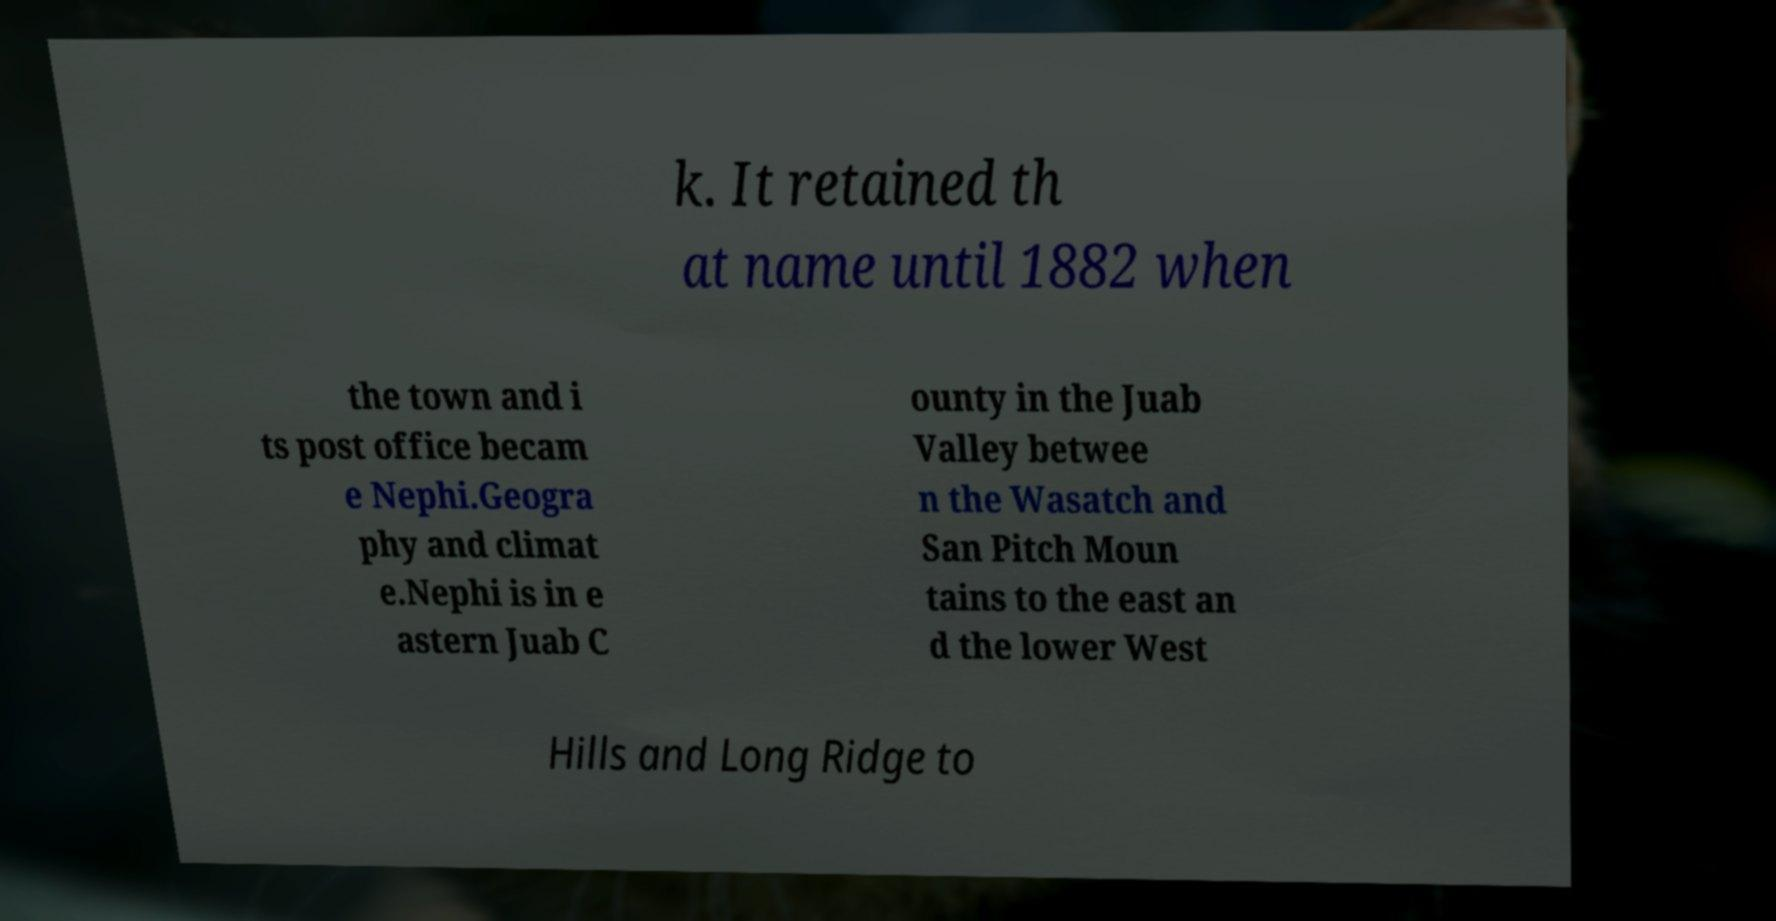I need the written content from this picture converted into text. Can you do that? k. It retained th at name until 1882 when the town and i ts post office becam e Nephi.Geogra phy and climat e.Nephi is in e astern Juab C ounty in the Juab Valley betwee n the Wasatch and San Pitch Moun tains to the east an d the lower West Hills and Long Ridge to 